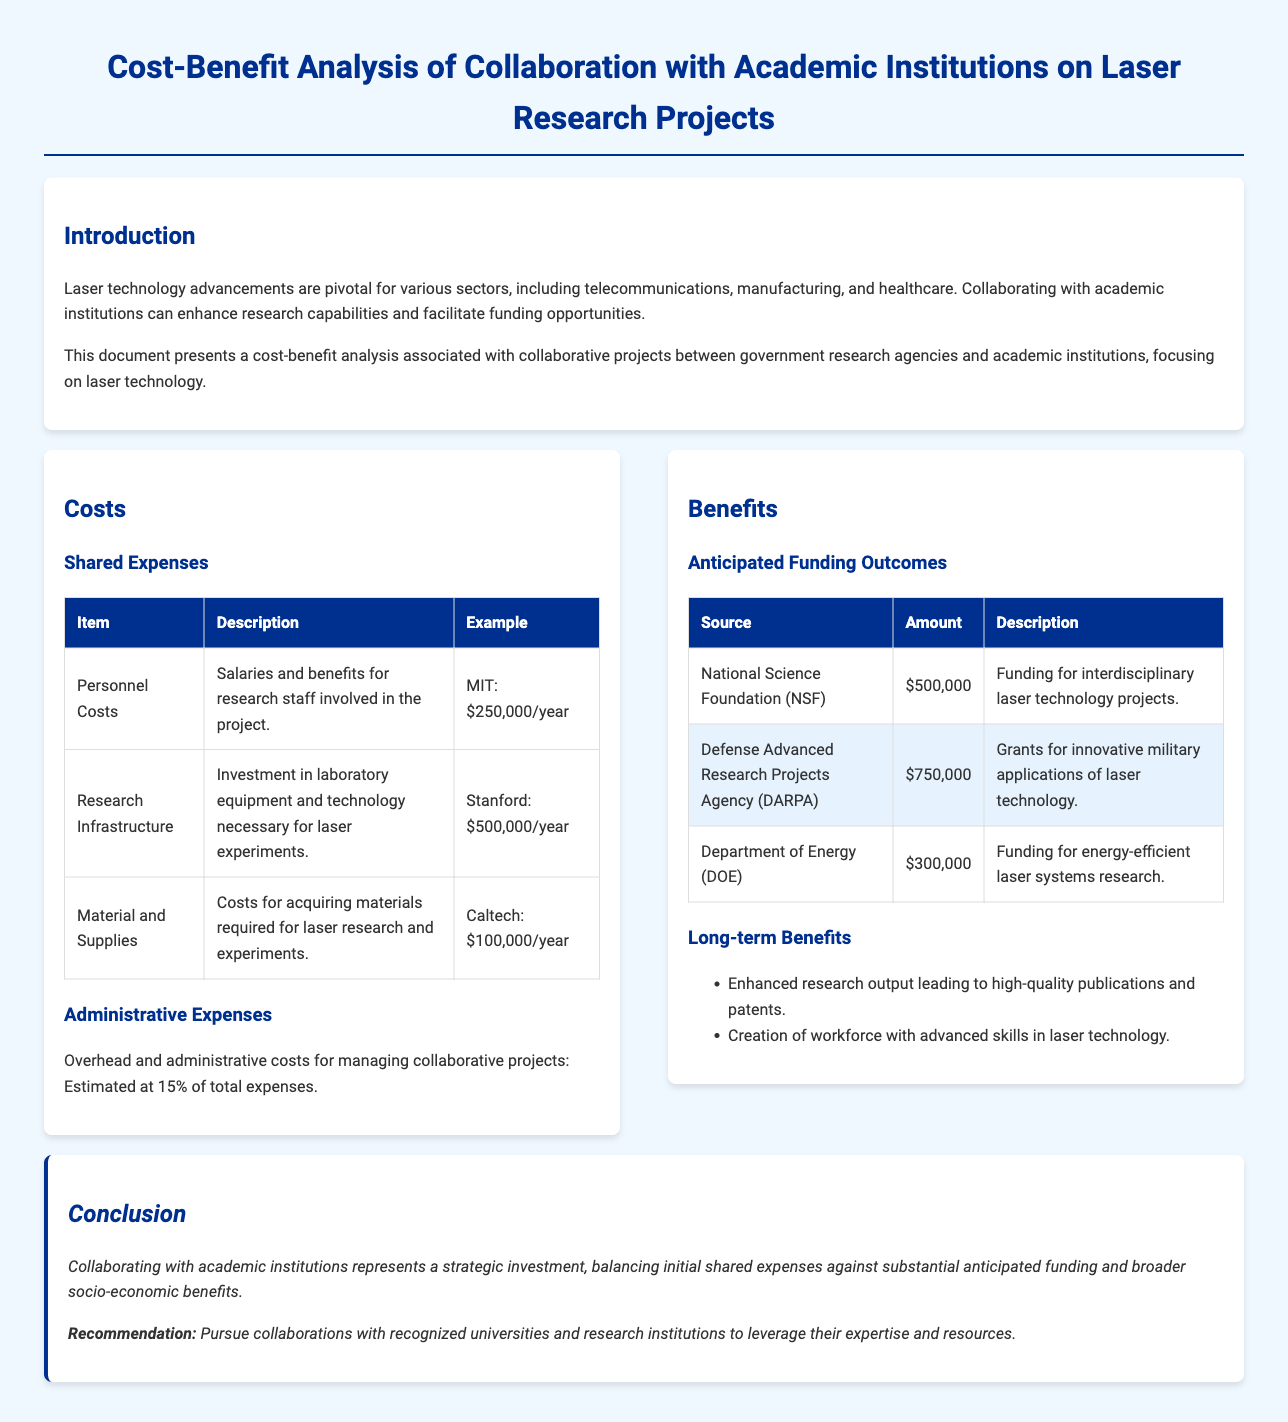What are the personnel costs at MIT? Personnel costs are listed for MIT, showing salaries and benefits for research staff involved in the project, which is $250,000/year.
Answer: $250,000/year What is the total anticipated funding from DARPA? The anticipated funding from DARPA is listed as $750,000, which is significant for innovative military applications.
Answer: $750,000 What percentage is estimated for administrative expenses? The document states that the overhead and administrative costs for managing collaborative projects are estimated at 15% of total expenses.
Answer: 15% What is one long-term benefit of collaboration mentioned? The document lists one long-term benefit as enhanced research output, leading to high-quality publications and patents.
Answer: Enhanced research output What is the total amount of funding from the National Science Foundation? The National Science Foundation funding is specifically mentioned as $500,000 for interdisciplinary laser technology projects.
Answer: $500,000 What institution has a research infrastructure cost of $500,000/year? The document indicates that Stanford has a research infrastructure cost of $500,000/year for laser experiments.
Answer: Stanford What is the main recommendation regarding academic collaborations? The conclusion emphasizes the recommendation to pursue collaborations with recognized universities to leverage their expertise and resources.
Answer: Pursue collaborations with recognized universities What type of funding does the Department of Energy support? The Department of Energy supports funding for energy-efficient laser systems research, as described in the anticipated funding outcomes section.
Answer: Energy-efficient laser systems research 